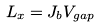Convert formula to latex. <formula><loc_0><loc_0><loc_500><loc_500>L _ { x } = J _ { b } V _ { g a p }</formula> 